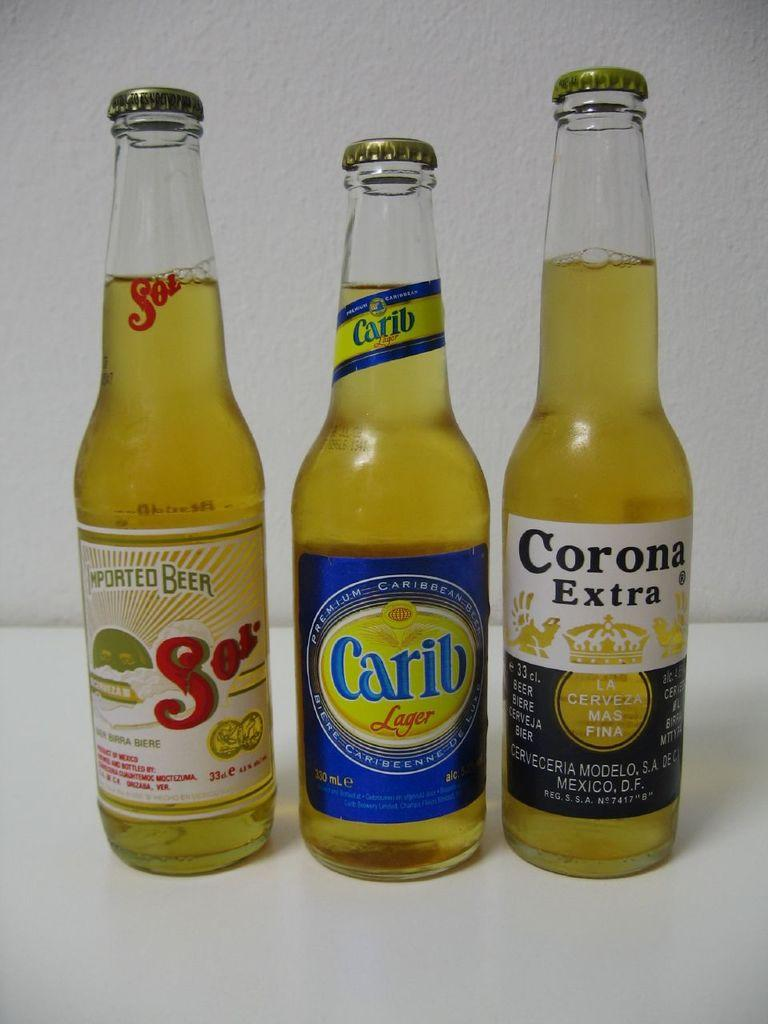<image>
Render a clear and concise summary of the photo. A set of three beer bottles, including Corona, Carib, and Sol. 